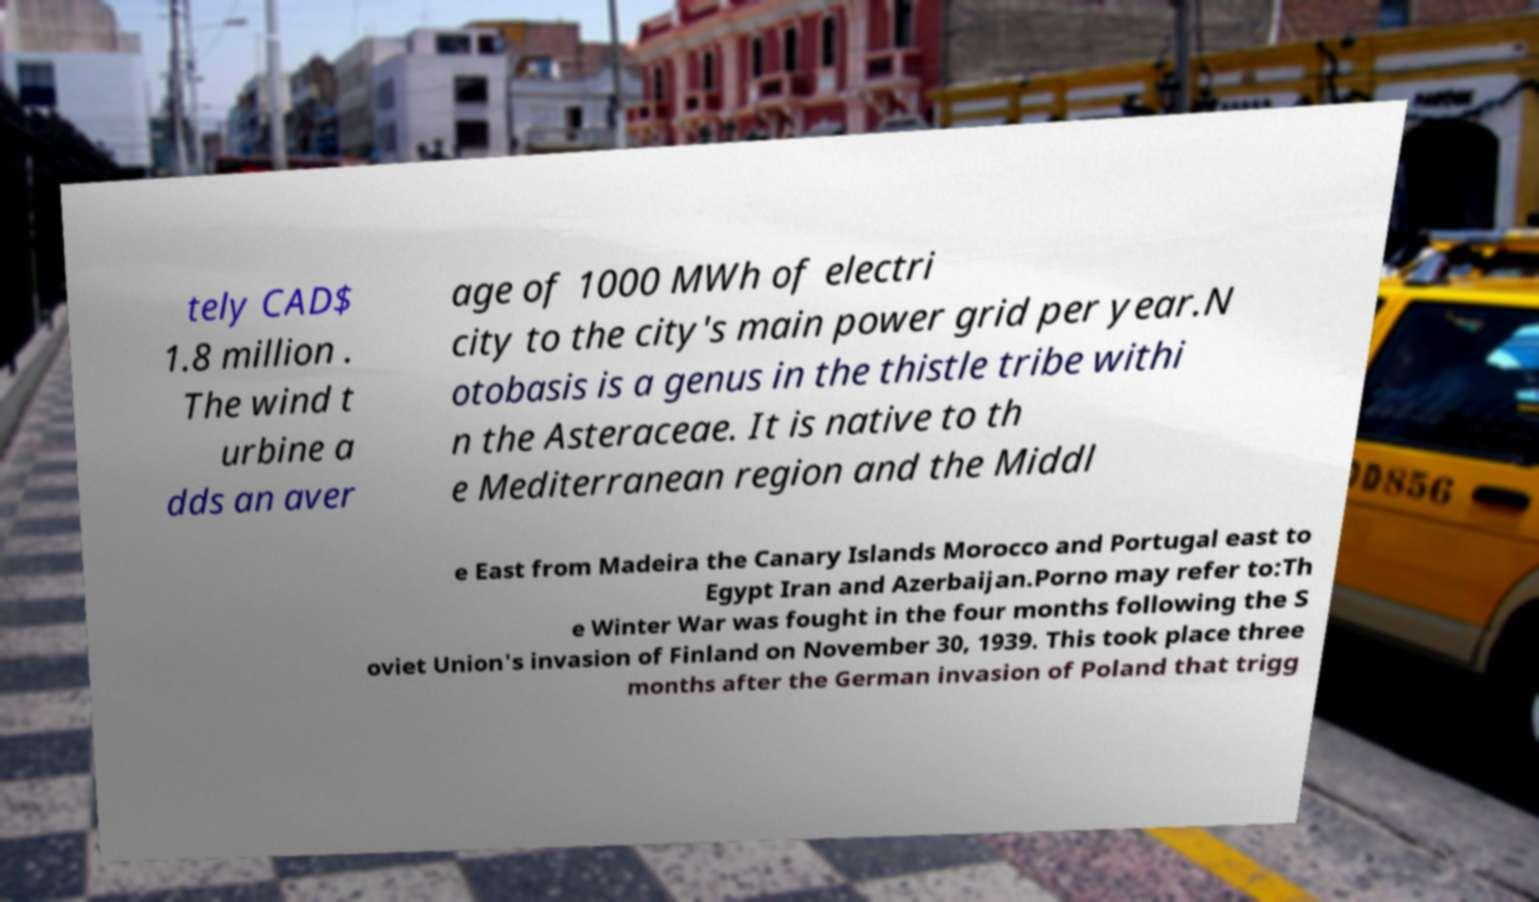Can you read and provide the text displayed in the image?This photo seems to have some interesting text. Can you extract and type it out for me? tely CAD$ 1.8 million . The wind t urbine a dds an aver age of 1000 MWh of electri city to the city's main power grid per year.N otobasis is a genus in the thistle tribe withi n the Asteraceae. It is native to th e Mediterranean region and the Middl e East from Madeira the Canary Islands Morocco and Portugal east to Egypt Iran and Azerbaijan.Porno may refer to:Th e Winter War was fought in the four months following the S oviet Union's invasion of Finland on November 30, 1939. This took place three months after the German invasion of Poland that trigg 